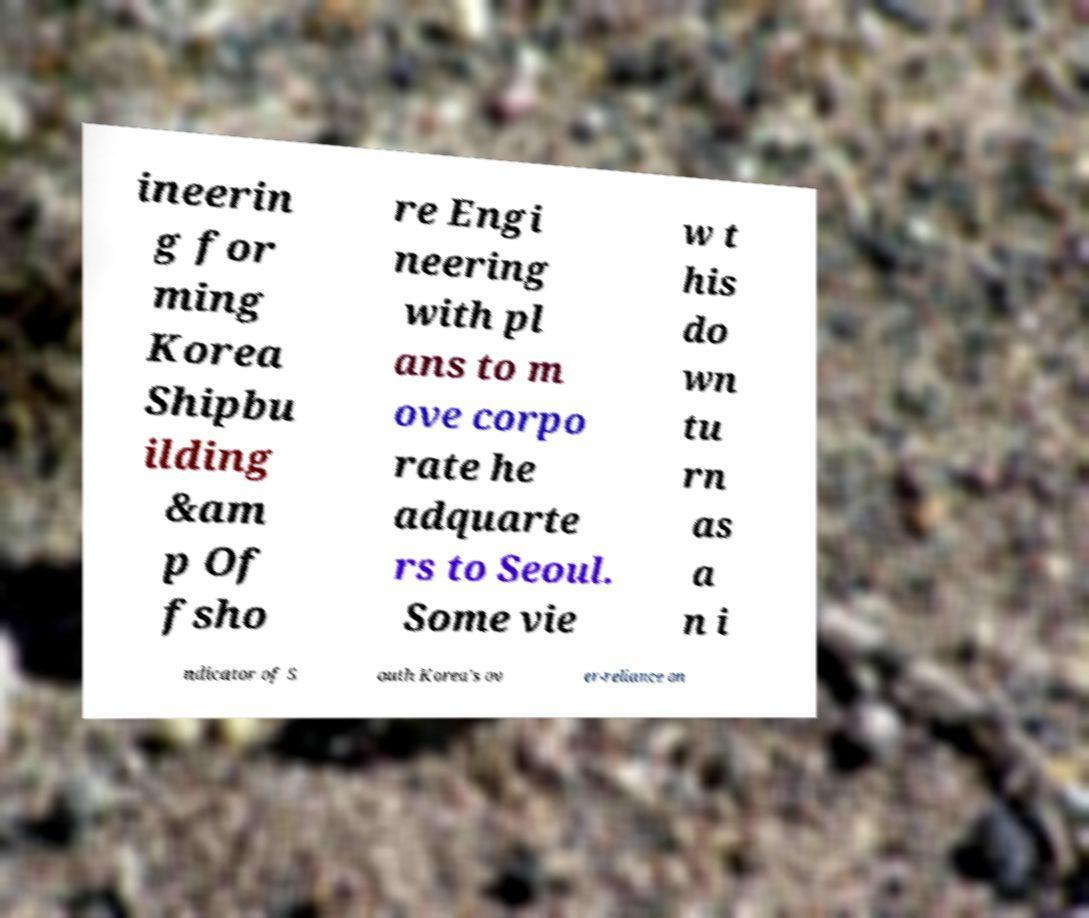Please read and relay the text visible in this image. What does it say? ineerin g for ming Korea Shipbu ilding &am p Of fsho re Engi neering with pl ans to m ove corpo rate he adquarte rs to Seoul. Some vie w t his do wn tu rn as a n i ndicator of S outh Korea's ov er-reliance on 